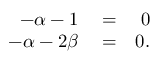<formula> <loc_0><loc_0><loc_500><loc_500>\begin{array} { r l r } { - \alpha - 1 } & = } & { 0 } \\ { - \alpha - 2 \beta } & = } & { 0 . } \end{array}</formula> 